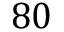<formula> <loc_0><loc_0><loc_500><loc_500>8 0</formula> 